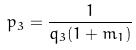Convert formula to latex. <formula><loc_0><loc_0><loc_500><loc_500>p _ { 3 } = \frac { 1 } { q _ { 3 } ( 1 + m _ { 1 } ) }</formula> 